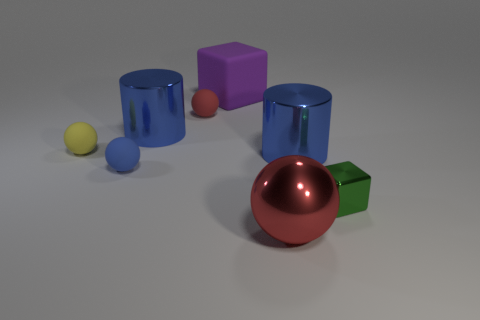Subtract 1 balls. How many balls are left? 3 Add 1 small cubes. How many objects exist? 9 Subtract all cylinders. How many objects are left? 6 Add 8 tiny blue metallic balls. How many tiny blue metallic balls exist? 8 Subtract 1 purple cubes. How many objects are left? 7 Subtract all tiny green things. Subtract all blue balls. How many objects are left? 6 Add 4 tiny metallic blocks. How many tiny metallic blocks are left? 5 